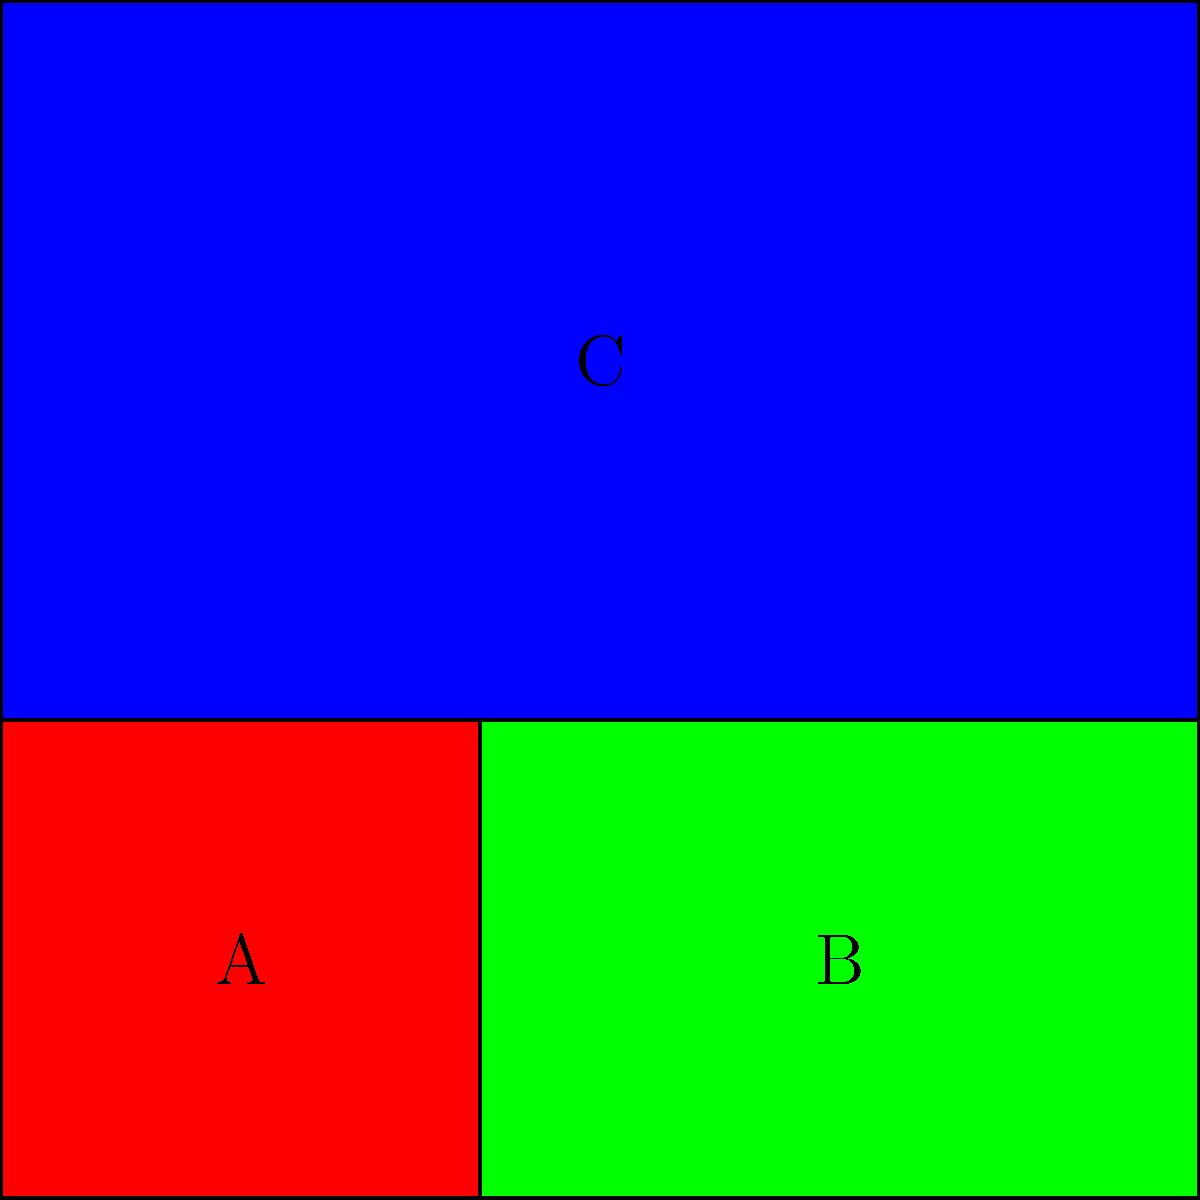Given the district map shown above, which machine learning technique would be most appropriate for detecting potential gerrymandering based on the shapes of the districts? To answer this question, let's consider the characteristics of gerrymandering and how they might be detected using machine learning:

1. Gerrymandering often results in irregularly shaped districts, as opposed to compact, geometrically simple shapes.

2. The key features we want to analyze are the shapes and boundaries of the districts.

3. We need a method that can process spatial data and identify patterns in shapes.

4. The problem is essentially one of image recognition and pattern detection.

5. Convolutional Neural Networks (CNNs) are particularly well-suited for image analysis tasks.

6. CNNs can learn to detect features such as irregular boundaries, elongated shapes, and other patterns associated with gerrymandering.

7. CNNs can be trained on a dataset of known gerrymandered and non-gerrymandered districts to learn the distinguishing features.

8. Once trained, a CNN could analyze new district maps and classify them as potentially gerrymandered or not.

9. This approach allows for objective, data-driven analysis of district shapes, which aligns with the need for meaningful change in the political system.

Given these considerations, Convolutional Neural Networks (CNNs) would be the most appropriate machine learning technique for this task.
Answer: Convolutional Neural Networks (CNNs) 